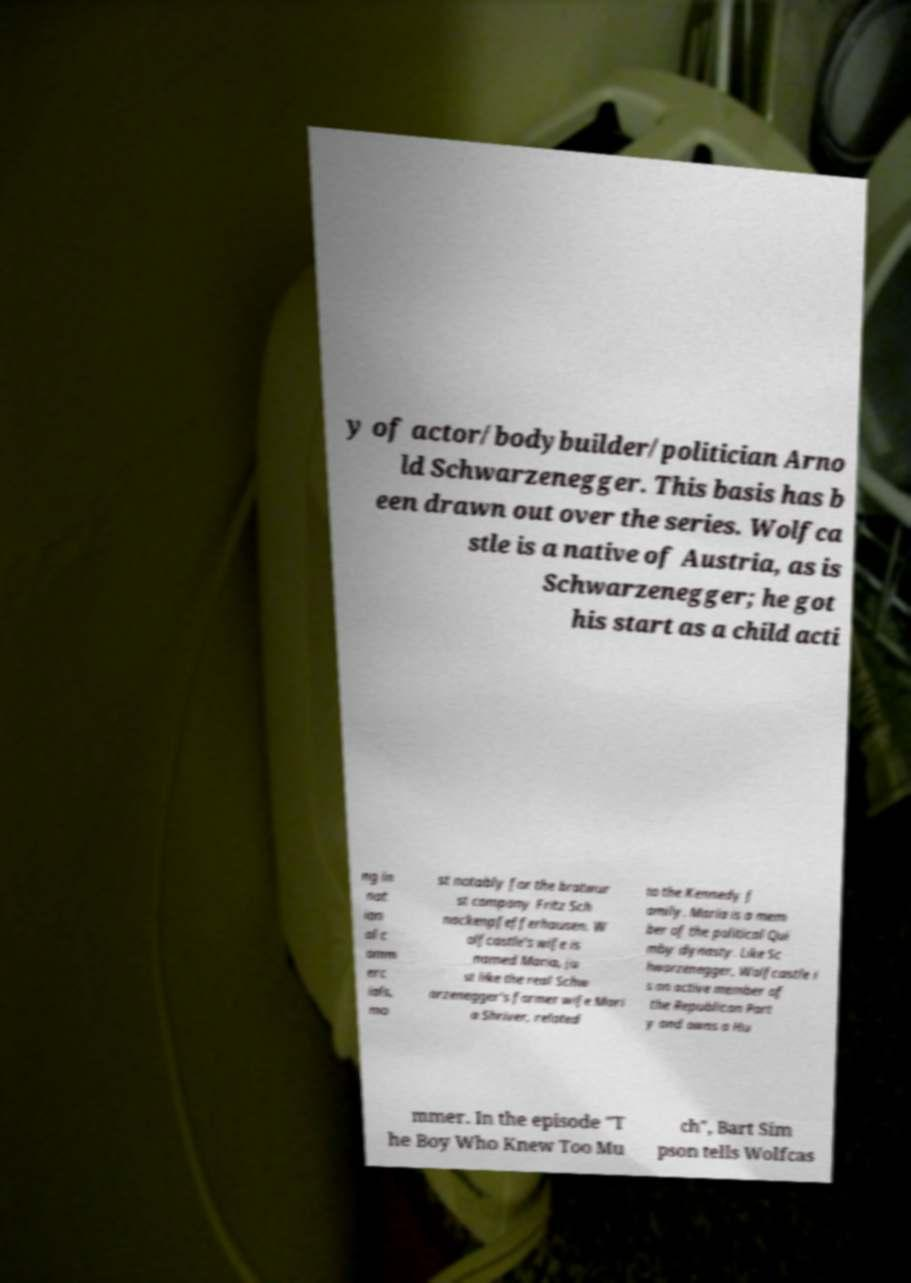Could you assist in decoding the text presented in this image and type it out clearly? y of actor/bodybuilder/politician Arno ld Schwarzenegger. This basis has b een drawn out over the series. Wolfca stle is a native of Austria, as is Schwarzenegger; he got his start as a child acti ng in nat ion al c omm erc ials, mo st notably for the bratwur st company Fritz Sch nackenpfefferhausen. W olfcastle's wife is named Maria, ju st like the real Schw arzenegger's former wife Mari a Shriver, related to the Kennedy f amily. Maria is a mem ber of the political Qui mby dynasty. Like Sc hwarzenegger, Wolfcastle i s an active member of the Republican Part y and owns a Hu mmer. In the episode "T he Boy Who Knew Too Mu ch", Bart Sim pson tells Wolfcas 